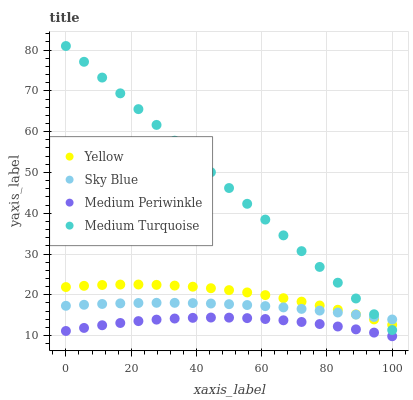Does Medium Periwinkle have the minimum area under the curve?
Answer yes or no. Yes. Does Medium Turquoise have the maximum area under the curve?
Answer yes or no. Yes. Does Medium Turquoise have the minimum area under the curve?
Answer yes or no. No. Does Medium Periwinkle have the maximum area under the curve?
Answer yes or no. No. Is Medium Turquoise the smoothest?
Answer yes or no. Yes. Is Medium Periwinkle the roughest?
Answer yes or no. Yes. Is Medium Periwinkle the smoothest?
Answer yes or no. No. Is Medium Turquoise the roughest?
Answer yes or no. No. Does Medium Periwinkle have the lowest value?
Answer yes or no. Yes. Does Medium Turquoise have the lowest value?
Answer yes or no. No. Does Medium Turquoise have the highest value?
Answer yes or no. Yes. Does Medium Periwinkle have the highest value?
Answer yes or no. No. Is Medium Periwinkle less than Medium Turquoise?
Answer yes or no. Yes. Is Medium Turquoise greater than Medium Periwinkle?
Answer yes or no. Yes. Does Sky Blue intersect Medium Turquoise?
Answer yes or no. Yes. Is Sky Blue less than Medium Turquoise?
Answer yes or no. No. Is Sky Blue greater than Medium Turquoise?
Answer yes or no. No. Does Medium Periwinkle intersect Medium Turquoise?
Answer yes or no. No. 